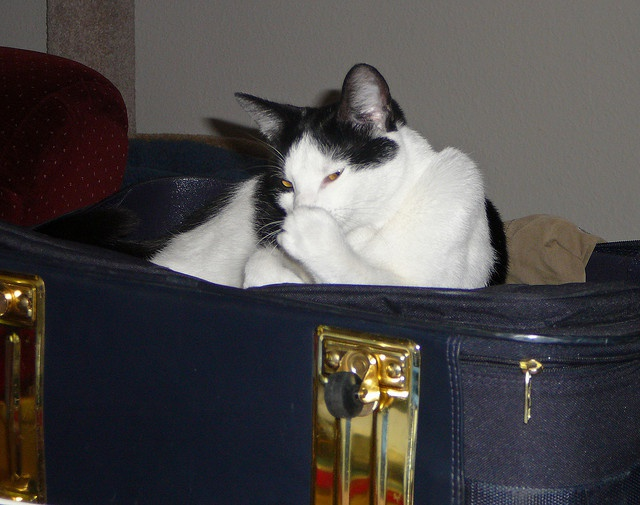Describe the objects in this image and their specific colors. I can see suitcase in gray, black, and olive tones and cat in gray, lightgray, black, and darkgray tones in this image. 